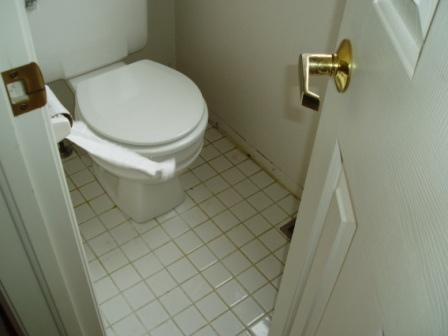Imagine you're giving a video tour of the bathroom in the image. Describe what you see in a conversational tone. As we enter this bathroom, we can see a white porcelain toilet with a closed wooden seat and a silver flush lever. Just beside it, there's an almost-empty roll of toilet paper. The floor's tiles look a little dirty, and there's a vent too. On the left side, there's a wooden door with a gold handle and a door stopper. Describe the image focusing on the condition of the floor and the location of the vent. The bathroom has a dirty tiled floor with several white tiles and a floor vent located close to the lower-right corner of the room. Describe the scene captured in the image with the least possible number of words. A bathroom with a closed white porcelain toilet, brass door handle, and a wooden door. List the elements and fixtures present in the bathroom shown in the image. White porcelain toilet, wooden toilet seat, silver flush lever, toilet paper holder, almost-empty toilet paper roll, dirty tiled floor, floor vent, white baseboards, wooden door, gold door handle, brass screw, door stopper, door latch. Give a detailed overview of the bathroom shown in the image and its fixtures. The bathroom features a white porcelain toilet with a closed wooden seat, a silver flush lever, and a toilet paper holder with an almost empty roll. The floor has dirty tiles, a vent, and white baseboards. A wooden door with a gold handle and brass screw on the frame has a door stopper and latch. Explain the layout of the bathroom in the image, highlighting the position of the toilet and the door. The bathroom has a white porcelain toilet with a closed wooden seat and a silver flush lever positioned near the lower-left corner. The wooden door with a gold handle and brass screw on its frame is on the left side of the toilet. Describe any signs of wear or aging in the bathroom depicted in the image. The bathroom shows a dirty tile floor, and the wooden door frame has a brass screw. The toilet paper holder has an almost empty roll, suggesting the bathroom has been in use for some time. Describe the current state of the bathroom in the image, including its floor and fixtures. The bathroom has a dirty tiled floor with a floor vent and white baseboards. It features a white porcelain toilet with a wooden seat and a silver flush lever, an almost empty roll of toilet paper, and a wooden door with a gold door handle and a brass screw on the frame. Mention the key objects visible in the image along with their primary colors. A white wooden toilet seat, brass door handle, white wooden door frame, white porcelain toilet, dirty bathroom floor, floor vent, empty roll of toilet paper, silver toilet flush lever, wooden bathroom door. Briefly mention the range of colors seen in the image, focusing on the bathroom fixtures and the door. The image consists of a white porcelain toilet, a white wooden toilet seat, a silver flush lever, a gold door handle, and a light brown wooden door. 